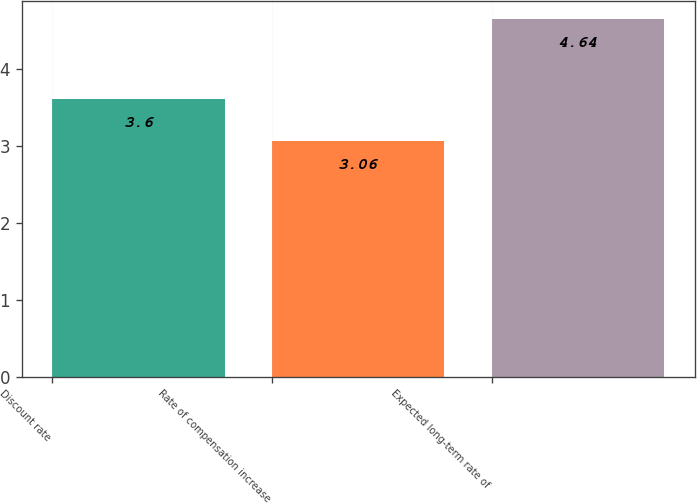Convert chart to OTSL. <chart><loc_0><loc_0><loc_500><loc_500><bar_chart><fcel>Discount rate<fcel>Rate of compensation increase<fcel>Expected long-term rate of<nl><fcel>3.6<fcel>3.06<fcel>4.64<nl></chart> 